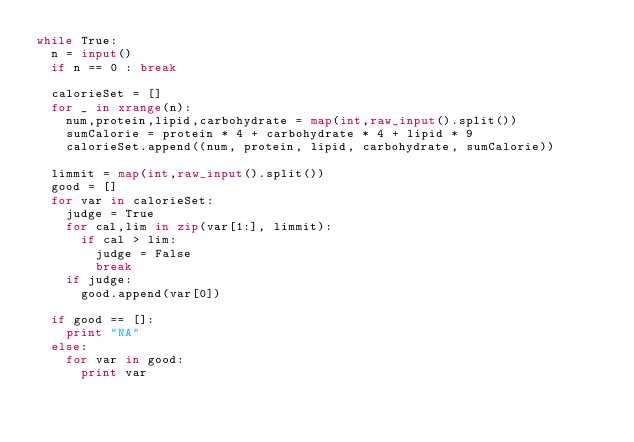<code> <loc_0><loc_0><loc_500><loc_500><_Python_>while True:
	n = input()
	if n == 0 : break

	calorieSet = []
	for _ in xrange(n):
		num,protein,lipid,carbohydrate = map(int,raw_input().split())
		sumCalorie = protein * 4 + carbohydrate * 4 + lipid * 9
		calorieSet.append((num, protein, lipid, carbohydrate, sumCalorie))
	
	limmit = map(int,raw_input().split())
	good = []
	for var in calorieSet:
		judge = True
		for cal,lim in zip(var[1:], limmit):
			if cal > lim:
				judge = False
				break
		if judge:
			good.append(var[0])
			
	if good == []:
		print "NA"
	else:
		for var in good:
			print var</code> 